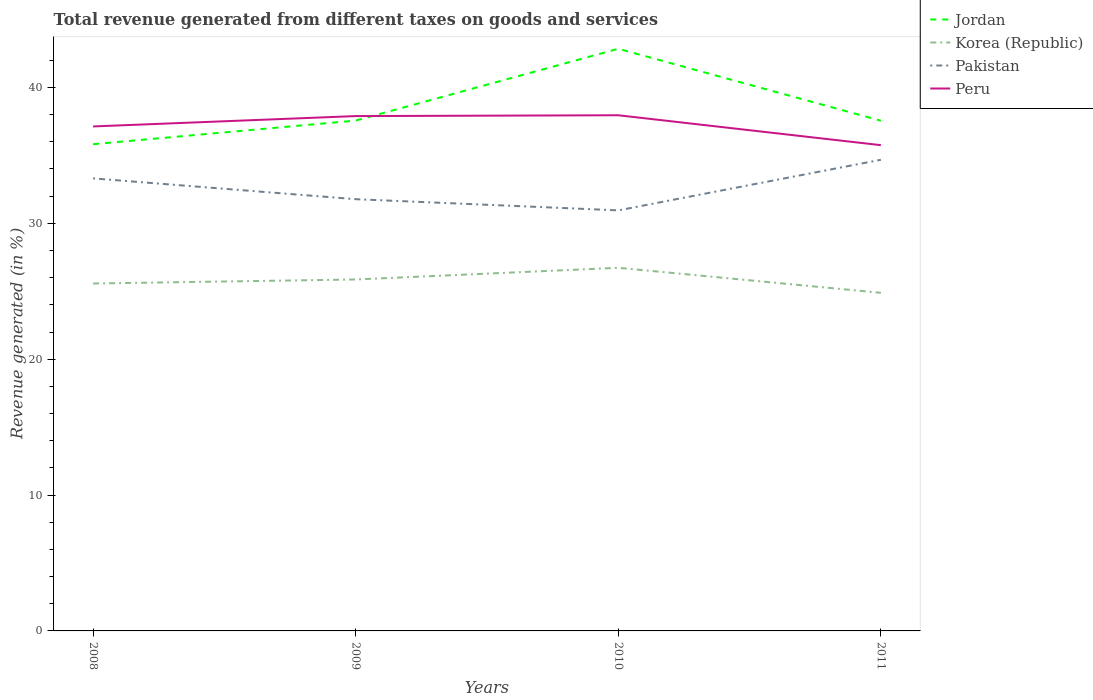Across all years, what is the maximum total revenue generated in Pakistan?
Provide a succinct answer. 30.95. What is the total total revenue generated in Pakistan in the graph?
Give a very brief answer. 2.35. What is the difference between the highest and the second highest total revenue generated in Peru?
Offer a terse response. 2.2. What is the difference between the highest and the lowest total revenue generated in Jordan?
Make the answer very short. 1. Is the total revenue generated in Korea (Republic) strictly greater than the total revenue generated in Pakistan over the years?
Your answer should be compact. Yes. How many years are there in the graph?
Keep it short and to the point. 4. What is the difference between two consecutive major ticks on the Y-axis?
Offer a very short reply. 10. Are the values on the major ticks of Y-axis written in scientific E-notation?
Offer a terse response. No. What is the title of the graph?
Offer a very short reply. Total revenue generated from different taxes on goods and services. What is the label or title of the Y-axis?
Your response must be concise. Revenue generated (in %). What is the Revenue generated (in %) of Jordan in 2008?
Provide a succinct answer. 35.82. What is the Revenue generated (in %) in Korea (Republic) in 2008?
Keep it short and to the point. 25.57. What is the Revenue generated (in %) in Pakistan in 2008?
Provide a succinct answer. 33.31. What is the Revenue generated (in %) of Peru in 2008?
Make the answer very short. 37.13. What is the Revenue generated (in %) in Jordan in 2009?
Give a very brief answer. 37.56. What is the Revenue generated (in %) in Korea (Republic) in 2009?
Your response must be concise. 25.87. What is the Revenue generated (in %) of Pakistan in 2009?
Ensure brevity in your answer.  31.78. What is the Revenue generated (in %) of Peru in 2009?
Give a very brief answer. 37.89. What is the Revenue generated (in %) of Jordan in 2010?
Keep it short and to the point. 42.85. What is the Revenue generated (in %) in Korea (Republic) in 2010?
Provide a short and direct response. 26.73. What is the Revenue generated (in %) of Pakistan in 2010?
Provide a short and direct response. 30.95. What is the Revenue generated (in %) of Peru in 2010?
Give a very brief answer. 37.95. What is the Revenue generated (in %) of Jordan in 2011?
Offer a terse response. 37.55. What is the Revenue generated (in %) in Korea (Republic) in 2011?
Provide a short and direct response. 24.88. What is the Revenue generated (in %) in Pakistan in 2011?
Offer a terse response. 34.68. What is the Revenue generated (in %) in Peru in 2011?
Your answer should be compact. 35.75. Across all years, what is the maximum Revenue generated (in %) in Jordan?
Provide a succinct answer. 42.85. Across all years, what is the maximum Revenue generated (in %) of Korea (Republic)?
Ensure brevity in your answer.  26.73. Across all years, what is the maximum Revenue generated (in %) of Pakistan?
Keep it short and to the point. 34.68. Across all years, what is the maximum Revenue generated (in %) in Peru?
Your answer should be compact. 37.95. Across all years, what is the minimum Revenue generated (in %) in Jordan?
Your response must be concise. 35.82. Across all years, what is the minimum Revenue generated (in %) of Korea (Republic)?
Offer a very short reply. 24.88. Across all years, what is the minimum Revenue generated (in %) of Pakistan?
Offer a very short reply. 30.95. Across all years, what is the minimum Revenue generated (in %) in Peru?
Ensure brevity in your answer.  35.75. What is the total Revenue generated (in %) of Jordan in the graph?
Give a very brief answer. 153.78. What is the total Revenue generated (in %) in Korea (Republic) in the graph?
Your answer should be compact. 103.05. What is the total Revenue generated (in %) in Pakistan in the graph?
Your answer should be compact. 130.71. What is the total Revenue generated (in %) of Peru in the graph?
Offer a very short reply. 148.73. What is the difference between the Revenue generated (in %) in Jordan in 2008 and that in 2009?
Offer a very short reply. -1.74. What is the difference between the Revenue generated (in %) in Korea (Republic) in 2008 and that in 2009?
Give a very brief answer. -0.3. What is the difference between the Revenue generated (in %) in Pakistan in 2008 and that in 2009?
Offer a terse response. 1.53. What is the difference between the Revenue generated (in %) of Peru in 2008 and that in 2009?
Offer a terse response. -0.76. What is the difference between the Revenue generated (in %) in Jordan in 2008 and that in 2010?
Your answer should be very brief. -7.02. What is the difference between the Revenue generated (in %) in Korea (Republic) in 2008 and that in 2010?
Your answer should be compact. -1.16. What is the difference between the Revenue generated (in %) of Pakistan in 2008 and that in 2010?
Your answer should be very brief. 2.35. What is the difference between the Revenue generated (in %) of Peru in 2008 and that in 2010?
Offer a very short reply. -0.82. What is the difference between the Revenue generated (in %) in Jordan in 2008 and that in 2011?
Make the answer very short. -1.73. What is the difference between the Revenue generated (in %) in Korea (Republic) in 2008 and that in 2011?
Provide a short and direct response. 0.69. What is the difference between the Revenue generated (in %) in Pakistan in 2008 and that in 2011?
Provide a succinct answer. -1.37. What is the difference between the Revenue generated (in %) of Peru in 2008 and that in 2011?
Your answer should be very brief. 1.38. What is the difference between the Revenue generated (in %) of Jordan in 2009 and that in 2010?
Give a very brief answer. -5.28. What is the difference between the Revenue generated (in %) of Korea (Republic) in 2009 and that in 2010?
Keep it short and to the point. -0.86. What is the difference between the Revenue generated (in %) of Pakistan in 2009 and that in 2010?
Your answer should be very brief. 0.82. What is the difference between the Revenue generated (in %) of Peru in 2009 and that in 2010?
Your answer should be compact. -0.06. What is the difference between the Revenue generated (in %) in Jordan in 2009 and that in 2011?
Provide a short and direct response. 0.01. What is the difference between the Revenue generated (in %) in Korea (Republic) in 2009 and that in 2011?
Give a very brief answer. 0.98. What is the difference between the Revenue generated (in %) in Pakistan in 2009 and that in 2011?
Offer a very short reply. -2.9. What is the difference between the Revenue generated (in %) in Peru in 2009 and that in 2011?
Ensure brevity in your answer.  2.14. What is the difference between the Revenue generated (in %) in Jordan in 2010 and that in 2011?
Give a very brief answer. 5.29. What is the difference between the Revenue generated (in %) in Korea (Republic) in 2010 and that in 2011?
Ensure brevity in your answer.  1.84. What is the difference between the Revenue generated (in %) in Pakistan in 2010 and that in 2011?
Your response must be concise. -3.72. What is the difference between the Revenue generated (in %) in Peru in 2010 and that in 2011?
Keep it short and to the point. 2.2. What is the difference between the Revenue generated (in %) in Jordan in 2008 and the Revenue generated (in %) in Korea (Republic) in 2009?
Your answer should be very brief. 9.96. What is the difference between the Revenue generated (in %) in Jordan in 2008 and the Revenue generated (in %) in Pakistan in 2009?
Offer a very short reply. 4.05. What is the difference between the Revenue generated (in %) in Jordan in 2008 and the Revenue generated (in %) in Peru in 2009?
Your answer should be compact. -2.07. What is the difference between the Revenue generated (in %) in Korea (Republic) in 2008 and the Revenue generated (in %) in Pakistan in 2009?
Your answer should be compact. -6.21. What is the difference between the Revenue generated (in %) in Korea (Republic) in 2008 and the Revenue generated (in %) in Peru in 2009?
Your answer should be compact. -12.32. What is the difference between the Revenue generated (in %) in Pakistan in 2008 and the Revenue generated (in %) in Peru in 2009?
Keep it short and to the point. -4.59. What is the difference between the Revenue generated (in %) of Jordan in 2008 and the Revenue generated (in %) of Korea (Republic) in 2010?
Offer a very short reply. 9.1. What is the difference between the Revenue generated (in %) in Jordan in 2008 and the Revenue generated (in %) in Pakistan in 2010?
Make the answer very short. 4.87. What is the difference between the Revenue generated (in %) of Jordan in 2008 and the Revenue generated (in %) of Peru in 2010?
Give a very brief answer. -2.13. What is the difference between the Revenue generated (in %) of Korea (Republic) in 2008 and the Revenue generated (in %) of Pakistan in 2010?
Ensure brevity in your answer.  -5.38. What is the difference between the Revenue generated (in %) of Korea (Republic) in 2008 and the Revenue generated (in %) of Peru in 2010?
Ensure brevity in your answer.  -12.38. What is the difference between the Revenue generated (in %) in Pakistan in 2008 and the Revenue generated (in %) in Peru in 2010?
Give a very brief answer. -4.65. What is the difference between the Revenue generated (in %) in Jordan in 2008 and the Revenue generated (in %) in Korea (Republic) in 2011?
Offer a terse response. 10.94. What is the difference between the Revenue generated (in %) of Jordan in 2008 and the Revenue generated (in %) of Pakistan in 2011?
Your response must be concise. 1.15. What is the difference between the Revenue generated (in %) of Jordan in 2008 and the Revenue generated (in %) of Peru in 2011?
Provide a succinct answer. 0.07. What is the difference between the Revenue generated (in %) in Korea (Republic) in 2008 and the Revenue generated (in %) in Pakistan in 2011?
Your answer should be very brief. -9.11. What is the difference between the Revenue generated (in %) in Korea (Republic) in 2008 and the Revenue generated (in %) in Peru in 2011?
Ensure brevity in your answer.  -10.18. What is the difference between the Revenue generated (in %) in Pakistan in 2008 and the Revenue generated (in %) in Peru in 2011?
Ensure brevity in your answer.  -2.45. What is the difference between the Revenue generated (in %) of Jordan in 2009 and the Revenue generated (in %) of Korea (Republic) in 2010?
Give a very brief answer. 10.84. What is the difference between the Revenue generated (in %) of Jordan in 2009 and the Revenue generated (in %) of Pakistan in 2010?
Provide a succinct answer. 6.61. What is the difference between the Revenue generated (in %) of Jordan in 2009 and the Revenue generated (in %) of Peru in 2010?
Keep it short and to the point. -0.39. What is the difference between the Revenue generated (in %) of Korea (Republic) in 2009 and the Revenue generated (in %) of Pakistan in 2010?
Ensure brevity in your answer.  -5.09. What is the difference between the Revenue generated (in %) of Korea (Republic) in 2009 and the Revenue generated (in %) of Peru in 2010?
Your answer should be compact. -12.09. What is the difference between the Revenue generated (in %) of Pakistan in 2009 and the Revenue generated (in %) of Peru in 2010?
Ensure brevity in your answer.  -6.18. What is the difference between the Revenue generated (in %) of Jordan in 2009 and the Revenue generated (in %) of Korea (Republic) in 2011?
Ensure brevity in your answer.  12.68. What is the difference between the Revenue generated (in %) of Jordan in 2009 and the Revenue generated (in %) of Pakistan in 2011?
Give a very brief answer. 2.89. What is the difference between the Revenue generated (in %) in Jordan in 2009 and the Revenue generated (in %) in Peru in 2011?
Ensure brevity in your answer.  1.81. What is the difference between the Revenue generated (in %) in Korea (Republic) in 2009 and the Revenue generated (in %) in Pakistan in 2011?
Your answer should be very brief. -8.81. What is the difference between the Revenue generated (in %) of Korea (Republic) in 2009 and the Revenue generated (in %) of Peru in 2011?
Provide a short and direct response. -9.89. What is the difference between the Revenue generated (in %) of Pakistan in 2009 and the Revenue generated (in %) of Peru in 2011?
Your response must be concise. -3.98. What is the difference between the Revenue generated (in %) in Jordan in 2010 and the Revenue generated (in %) in Korea (Republic) in 2011?
Keep it short and to the point. 17.96. What is the difference between the Revenue generated (in %) in Jordan in 2010 and the Revenue generated (in %) in Pakistan in 2011?
Your answer should be very brief. 8.17. What is the difference between the Revenue generated (in %) in Jordan in 2010 and the Revenue generated (in %) in Peru in 2011?
Provide a short and direct response. 7.09. What is the difference between the Revenue generated (in %) of Korea (Republic) in 2010 and the Revenue generated (in %) of Pakistan in 2011?
Keep it short and to the point. -7.95. What is the difference between the Revenue generated (in %) of Korea (Republic) in 2010 and the Revenue generated (in %) of Peru in 2011?
Provide a succinct answer. -9.03. What is the difference between the Revenue generated (in %) in Pakistan in 2010 and the Revenue generated (in %) in Peru in 2011?
Offer a terse response. -4.8. What is the average Revenue generated (in %) in Jordan per year?
Keep it short and to the point. 38.45. What is the average Revenue generated (in %) in Korea (Republic) per year?
Provide a short and direct response. 25.76. What is the average Revenue generated (in %) of Pakistan per year?
Provide a succinct answer. 32.68. What is the average Revenue generated (in %) of Peru per year?
Provide a succinct answer. 37.18. In the year 2008, what is the difference between the Revenue generated (in %) of Jordan and Revenue generated (in %) of Korea (Republic)?
Your response must be concise. 10.25. In the year 2008, what is the difference between the Revenue generated (in %) of Jordan and Revenue generated (in %) of Pakistan?
Ensure brevity in your answer.  2.52. In the year 2008, what is the difference between the Revenue generated (in %) of Jordan and Revenue generated (in %) of Peru?
Give a very brief answer. -1.31. In the year 2008, what is the difference between the Revenue generated (in %) of Korea (Republic) and Revenue generated (in %) of Pakistan?
Your answer should be compact. -7.74. In the year 2008, what is the difference between the Revenue generated (in %) of Korea (Republic) and Revenue generated (in %) of Peru?
Offer a very short reply. -11.56. In the year 2008, what is the difference between the Revenue generated (in %) of Pakistan and Revenue generated (in %) of Peru?
Ensure brevity in your answer.  -3.82. In the year 2009, what is the difference between the Revenue generated (in %) of Jordan and Revenue generated (in %) of Korea (Republic)?
Offer a very short reply. 11.7. In the year 2009, what is the difference between the Revenue generated (in %) in Jordan and Revenue generated (in %) in Pakistan?
Keep it short and to the point. 5.79. In the year 2009, what is the difference between the Revenue generated (in %) of Jordan and Revenue generated (in %) of Peru?
Keep it short and to the point. -0.33. In the year 2009, what is the difference between the Revenue generated (in %) in Korea (Republic) and Revenue generated (in %) in Pakistan?
Your answer should be very brief. -5.91. In the year 2009, what is the difference between the Revenue generated (in %) of Korea (Republic) and Revenue generated (in %) of Peru?
Provide a succinct answer. -12.03. In the year 2009, what is the difference between the Revenue generated (in %) in Pakistan and Revenue generated (in %) in Peru?
Give a very brief answer. -6.12. In the year 2010, what is the difference between the Revenue generated (in %) of Jordan and Revenue generated (in %) of Korea (Republic)?
Your response must be concise. 16.12. In the year 2010, what is the difference between the Revenue generated (in %) of Jordan and Revenue generated (in %) of Pakistan?
Make the answer very short. 11.89. In the year 2010, what is the difference between the Revenue generated (in %) of Jordan and Revenue generated (in %) of Peru?
Make the answer very short. 4.89. In the year 2010, what is the difference between the Revenue generated (in %) in Korea (Republic) and Revenue generated (in %) in Pakistan?
Your response must be concise. -4.23. In the year 2010, what is the difference between the Revenue generated (in %) of Korea (Republic) and Revenue generated (in %) of Peru?
Give a very brief answer. -11.23. In the year 2010, what is the difference between the Revenue generated (in %) of Pakistan and Revenue generated (in %) of Peru?
Your response must be concise. -7. In the year 2011, what is the difference between the Revenue generated (in %) of Jordan and Revenue generated (in %) of Korea (Republic)?
Your answer should be very brief. 12.67. In the year 2011, what is the difference between the Revenue generated (in %) in Jordan and Revenue generated (in %) in Pakistan?
Provide a short and direct response. 2.88. In the year 2011, what is the difference between the Revenue generated (in %) in Jordan and Revenue generated (in %) in Peru?
Make the answer very short. 1.8. In the year 2011, what is the difference between the Revenue generated (in %) of Korea (Republic) and Revenue generated (in %) of Pakistan?
Provide a short and direct response. -9.79. In the year 2011, what is the difference between the Revenue generated (in %) in Korea (Republic) and Revenue generated (in %) in Peru?
Provide a short and direct response. -10.87. In the year 2011, what is the difference between the Revenue generated (in %) of Pakistan and Revenue generated (in %) of Peru?
Provide a succinct answer. -1.08. What is the ratio of the Revenue generated (in %) in Jordan in 2008 to that in 2009?
Your answer should be very brief. 0.95. What is the ratio of the Revenue generated (in %) of Korea (Republic) in 2008 to that in 2009?
Offer a very short reply. 0.99. What is the ratio of the Revenue generated (in %) in Pakistan in 2008 to that in 2009?
Make the answer very short. 1.05. What is the ratio of the Revenue generated (in %) of Peru in 2008 to that in 2009?
Your response must be concise. 0.98. What is the ratio of the Revenue generated (in %) in Jordan in 2008 to that in 2010?
Offer a very short reply. 0.84. What is the ratio of the Revenue generated (in %) of Korea (Republic) in 2008 to that in 2010?
Ensure brevity in your answer.  0.96. What is the ratio of the Revenue generated (in %) of Pakistan in 2008 to that in 2010?
Offer a terse response. 1.08. What is the ratio of the Revenue generated (in %) in Peru in 2008 to that in 2010?
Offer a terse response. 0.98. What is the ratio of the Revenue generated (in %) of Jordan in 2008 to that in 2011?
Give a very brief answer. 0.95. What is the ratio of the Revenue generated (in %) in Korea (Republic) in 2008 to that in 2011?
Give a very brief answer. 1.03. What is the ratio of the Revenue generated (in %) of Pakistan in 2008 to that in 2011?
Your answer should be compact. 0.96. What is the ratio of the Revenue generated (in %) in Peru in 2008 to that in 2011?
Your response must be concise. 1.04. What is the ratio of the Revenue generated (in %) of Jordan in 2009 to that in 2010?
Provide a short and direct response. 0.88. What is the ratio of the Revenue generated (in %) of Korea (Republic) in 2009 to that in 2010?
Your answer should be compact. 0.97. What is the ratio of the Revenue generated (in %) in Pakistan in 2009 to that in 2010?
Offer a terse response. 1.03. What is the ratio of the Revenue generated (in %) of Korea (Republic) in 2009 to that in 2011?
Your answer should be compact. 1.04. What is the ratio of the Revenue generated (in %) in Pakistan in 2009 to that in 2011?
Ensure brevity in your answer.  0.92. What is the ratio of the Revenue generated (in %) of Peru in 2009 to that in 2011?
Ensure brevity in your answer.  1.06. What is the ratio of the Revenue generated (in %) in Jordan in 2010 to that in 2011?
Keep it short and to the point. 1.14. What is the ratio of the Revenue generated (in %) of Korea (Republic) in 2010 to that in 2011?
Provide a short and direct response. 1.07. What is the ratio of the Revenue generated (in %) of Pakistan in 2010 to that in 2011?
Ensure brevity in your answer.  0.89. What is the ratio of the Revenue generated (in %) in Peru in 2010 to that in 2011?
Offer a very short reply. 1.06. What is the difference between the highest and the second highest Revenue generated (in %) of Jordan?
Offer a terse response. 5.28. What is the difference between the highest and the second highest Revenue generated (in %) of Korea (Republic)?
Your answer should be compact. 0.86. What is the difference between the highest and the second highest Revenue generated (in %) in Pakistan?
Give a very brief answer. 1.37. What is the difference between the highest and the second highest Revenue generated (in %) in Peru?
Offer a very short reply. 0.06. What is the difference between the highest and the lowest Revenue generated (in %) of Jordan?
Your answer should be compact. 7.02. What is the difference between the highest and the lowest Revenue generated (in %) of Korea (Republic)?
Give a very brief answer. 1.84. What is the difference between the highest and the lowest Revenue generated (in %) of Pakistan?
Give a very brief answer. 3.72. What is the difference between the highest and the lowest Revenue generated (in %) of Peru?
Your answer should be compact. 2.2. 